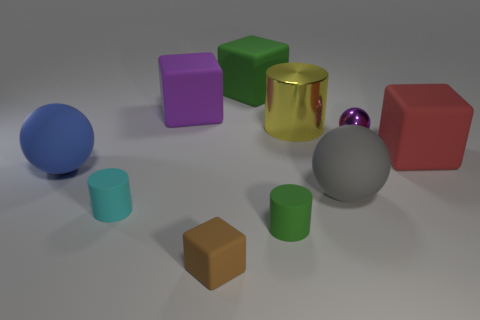Subtract all blocks. How many objects are left? 6 Add 7 tiny purple spheres. How many tiny purple spheres are left? 8 Add 4 big blue balls. How many big blue balls exist? 5 Subtract 0 yellow balls. How many objects are left? 10 Subtract all tiny green shiny things. Subtract all small green matte objects. How many objects are left? 9 